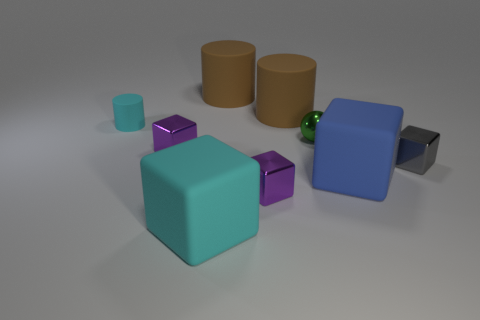What number of blue objects are either large matte objects or tiny rubber cylinders?
Make the answer very short. 1. There is a cyan object that is behind the big blue thing; what material is it?
Your answer should be compact. Rubber. Are there more tiny metal cubes than large brown matte things?
Provide a short and direct response. Yes. There is a shiny thing on the left side of the cyan rubber block; does it have the same shape as the big blue object?
Offer a very short reply. Yes. How many rubber objects are both behind the cyan cylinder and in front of the small cyan rubber cylinder?
Offer a very short reply. 0. How many big matte things have the same shape as the tiny rubber thing?
Keep it short and to the point. 2. There is a big cube on the right side of the cyan rubber object that is on the right side of the tiny cylinder; what color is it?
Keep it short and to the point. Blue. There is a gray shiny object; is it the same shape as the big thing to the right of the small green thing?
Your answer should be very brief. Yes. What is the material of the big cube right of the cyan matte object that is right of the cyan object that is behind the tiny gray metallic cube?
Provide a succinct answer. Rubber. Is there a yellow matte block of the same size as the green thing?
Your answer should be compact. No. 